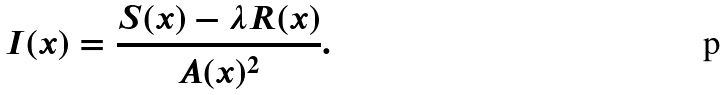Convert formula to latex. <formula><loc_0><loc_0><loc_500><loc_500>I ( x ) = \frac { S ( x ) - \lambda R ( x ) } { A ( x ) ^ { 2 } } .</formula> 